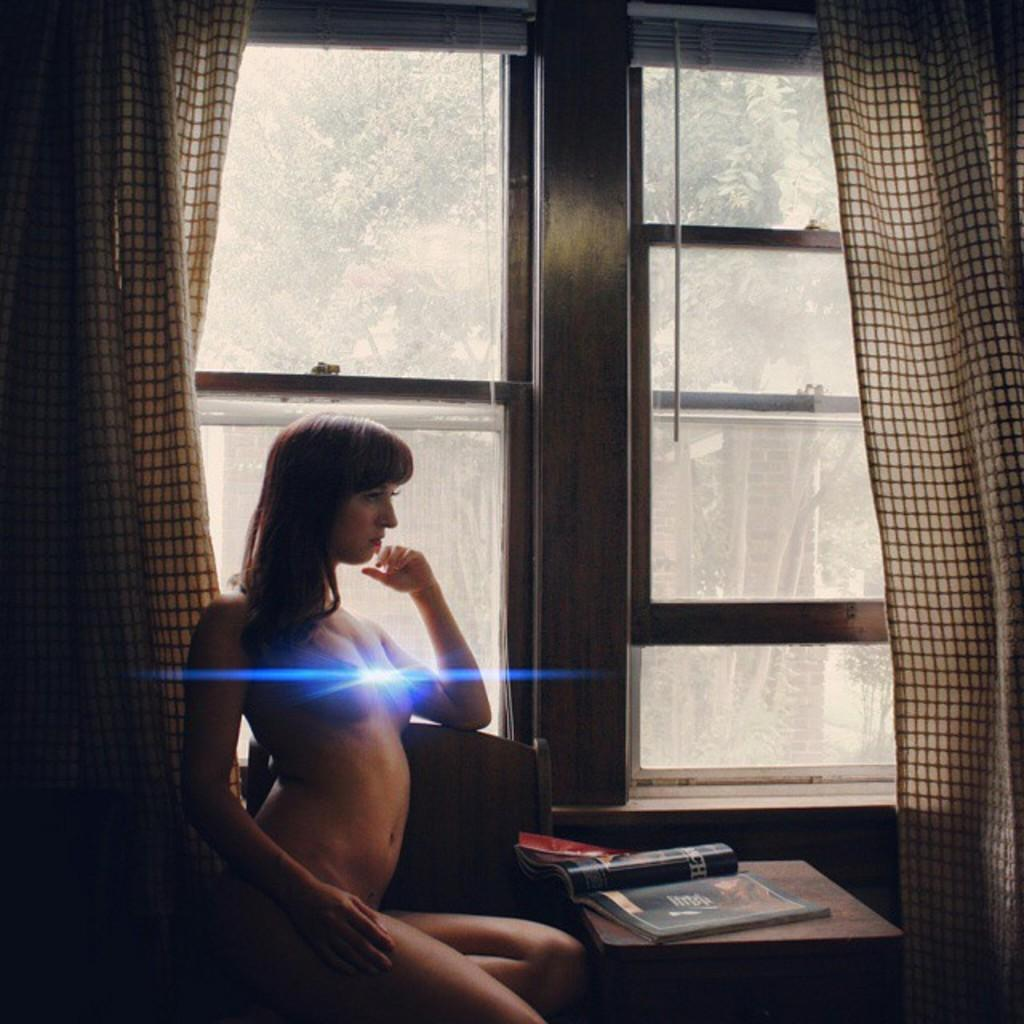Who is present in the image? There is a woman in the image. What is the woman doing in the image? The woman is sitting on a chair. Where is the chair located in relation to the window? The chair is near a window. What can be found on the table in the image? There are books on the table. What type of window treatment is present in the image? There is a curtain near the window. What can be seen through the window in the image? Trees are visible through the glass window. What type of acoustics can be heard from the church in the image? There is no church present in the image, so it's not possible to determine the acoustics. 